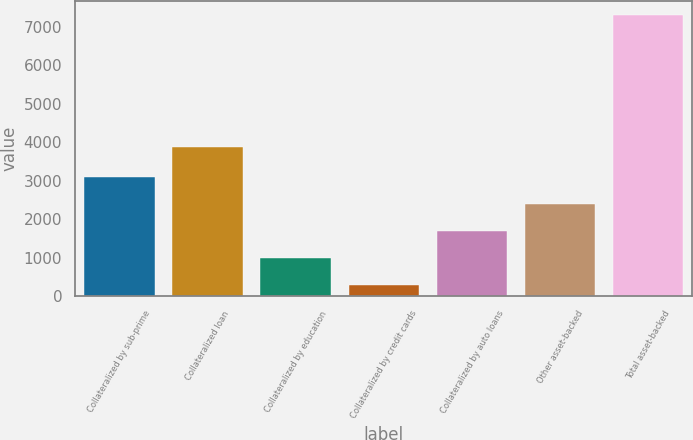Convert chart. <chart><loc_0><loc_0><loc_500><loc_500><bar_chart><fcel>Collateralized by sub-prime<fcel>Collateralized loan<fcel>Collateralized by education<fcel>Collateralized by credit cards<fcel>Collateralized by auto loans<fcel>Other asset-backed<fcel>Total asset-backed<nl><fcel>3089.4<fcel>3867<fcel>980.1<fcel>277<fcel>1683.2<fcel>2386.3<fcel>7308<nl></chart> 